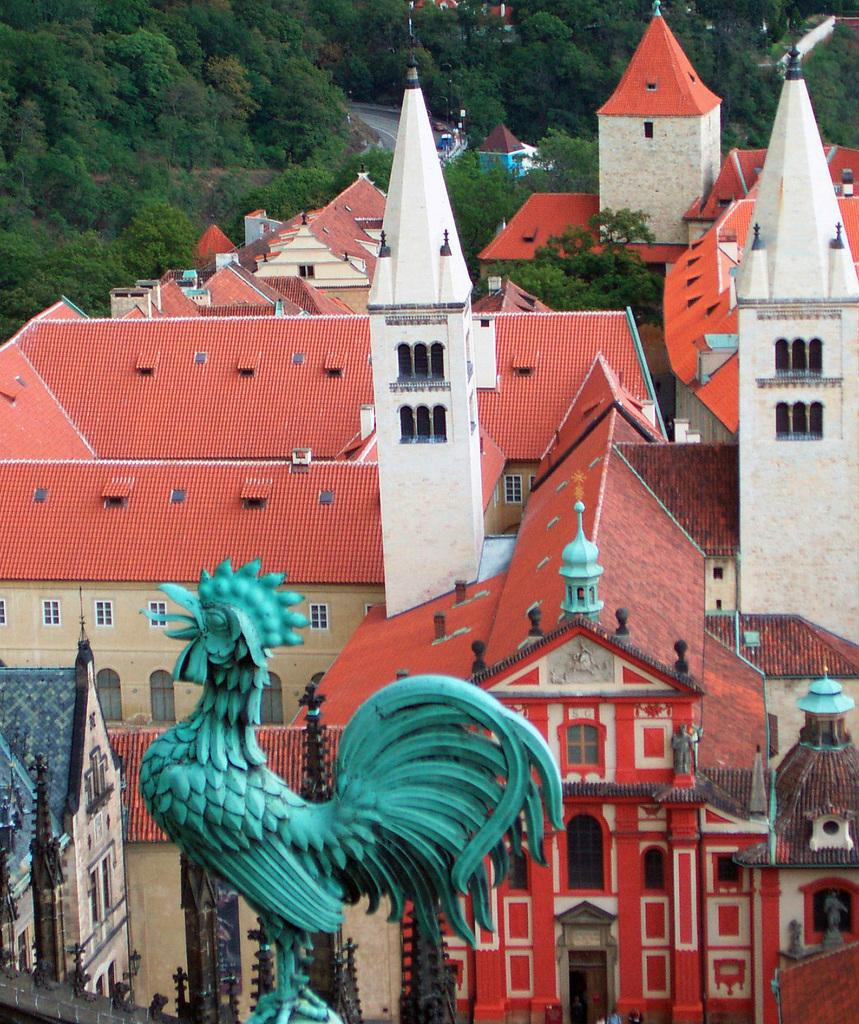What type of structures can be seen in the image? There are buildings in the image. What is the prominent feature in the front of the image? There is a statue of a hen in the front of the image. What can be seen in the background of the image? There are many trees in the background of the image. What channel is the statue of the hen tuned to in the image? The statue of the hen is not a television or any device that can be tuned to a channel; it is a statue. Is there any fog visible in the image? There is no mention of fog in the provided facts, and it is not visible in the image. 